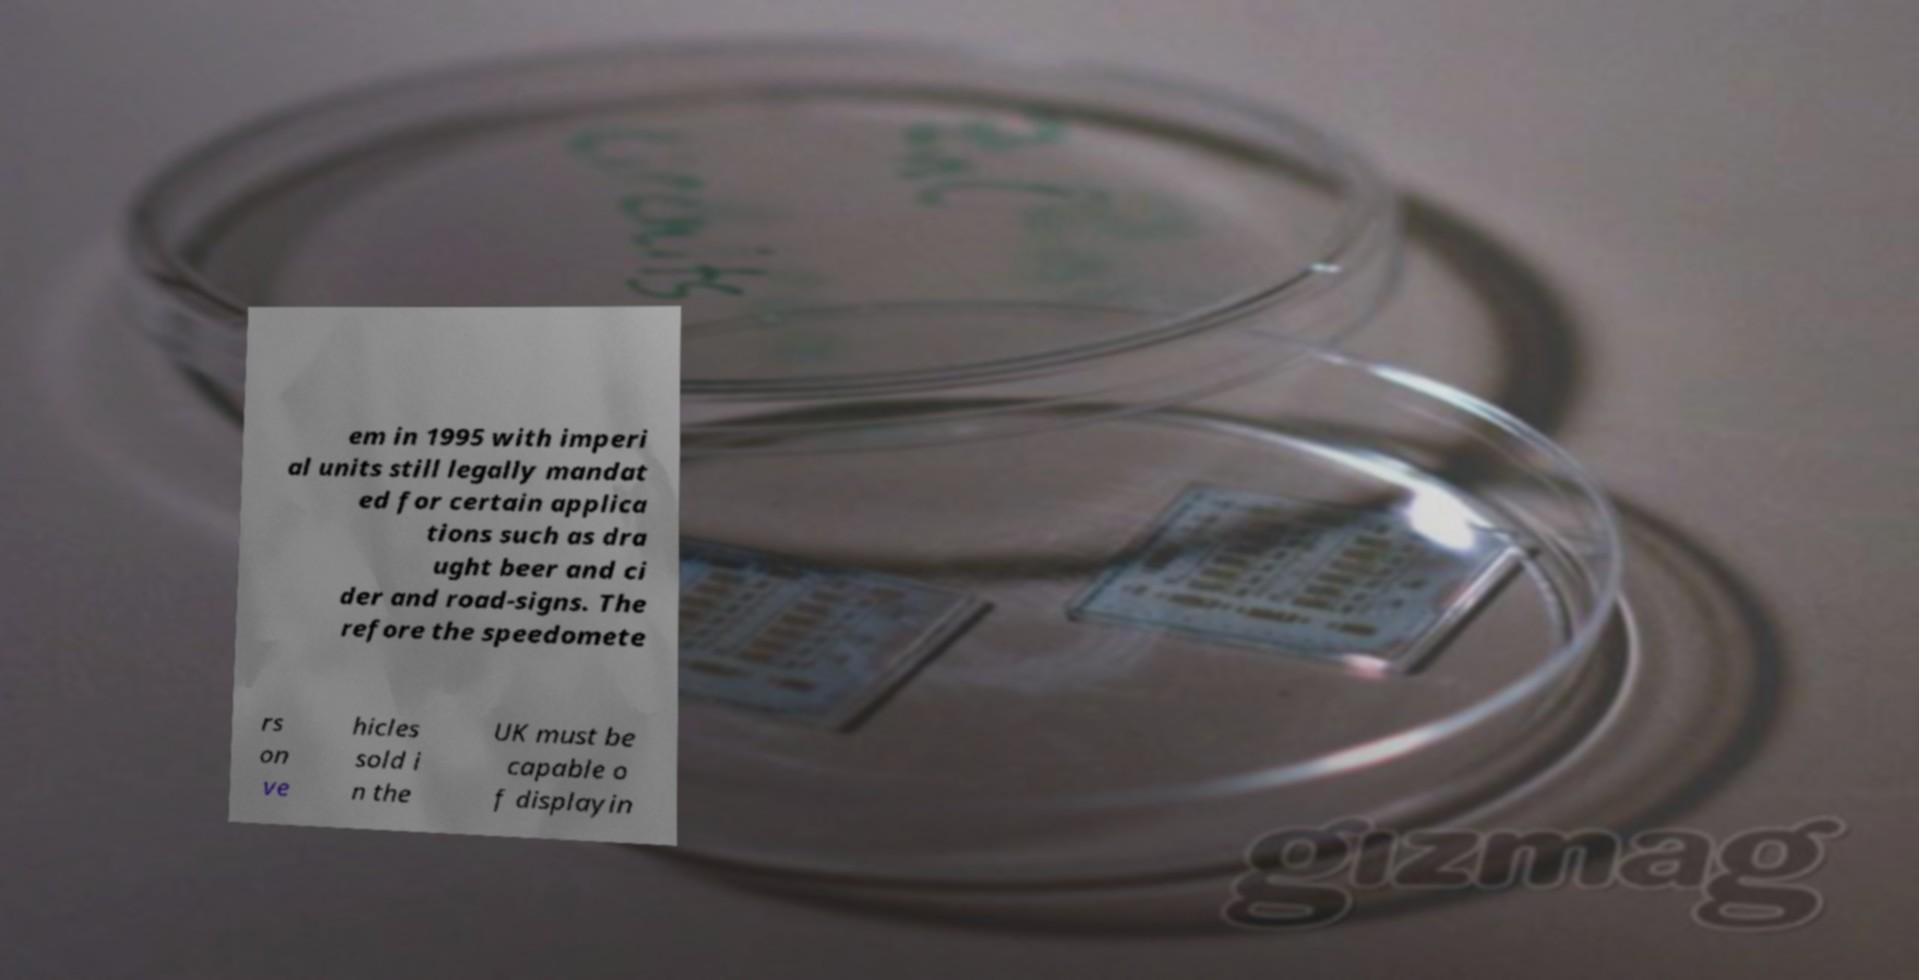There's text embedded in this image that I need extracted. Can you transcribe it verbatim? em in 1995 with imperi al units still legally mandat ed for certain applica tions such as dra ught beer and ci der and road-signs. The refore the speedomete rs on ve hicles sold i n the UK must be capable o f displayin 